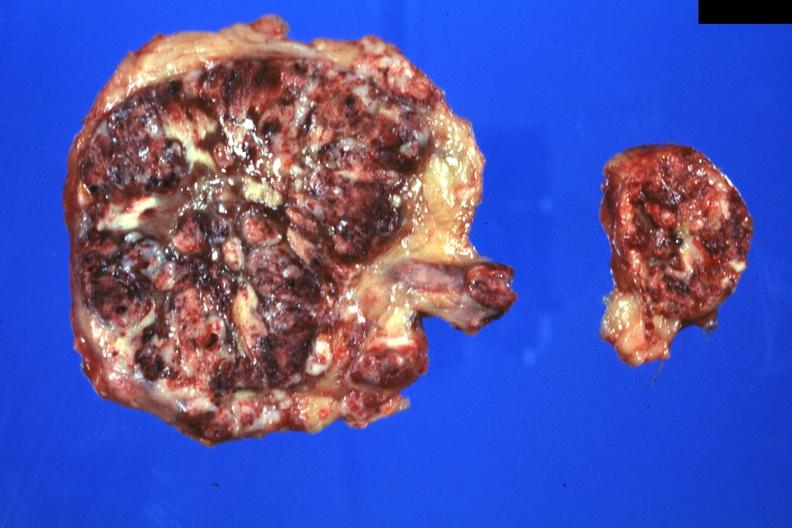s nipple duplication present?
Answer the question using a single word or phrase. No 